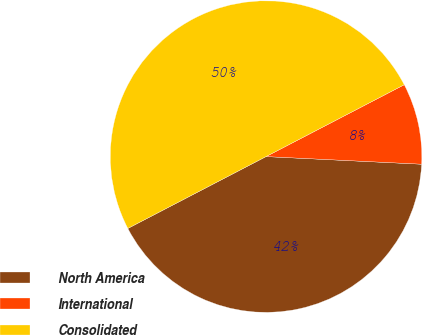<chart> <loc_0><loc_0><loc_500><loc_500><pie_chart><fcel>North America<fcel>International<fcel>Consolidated<nl><fcel>41.59%<fcel>8.41%<fcel>50.0%<nl></chart> 